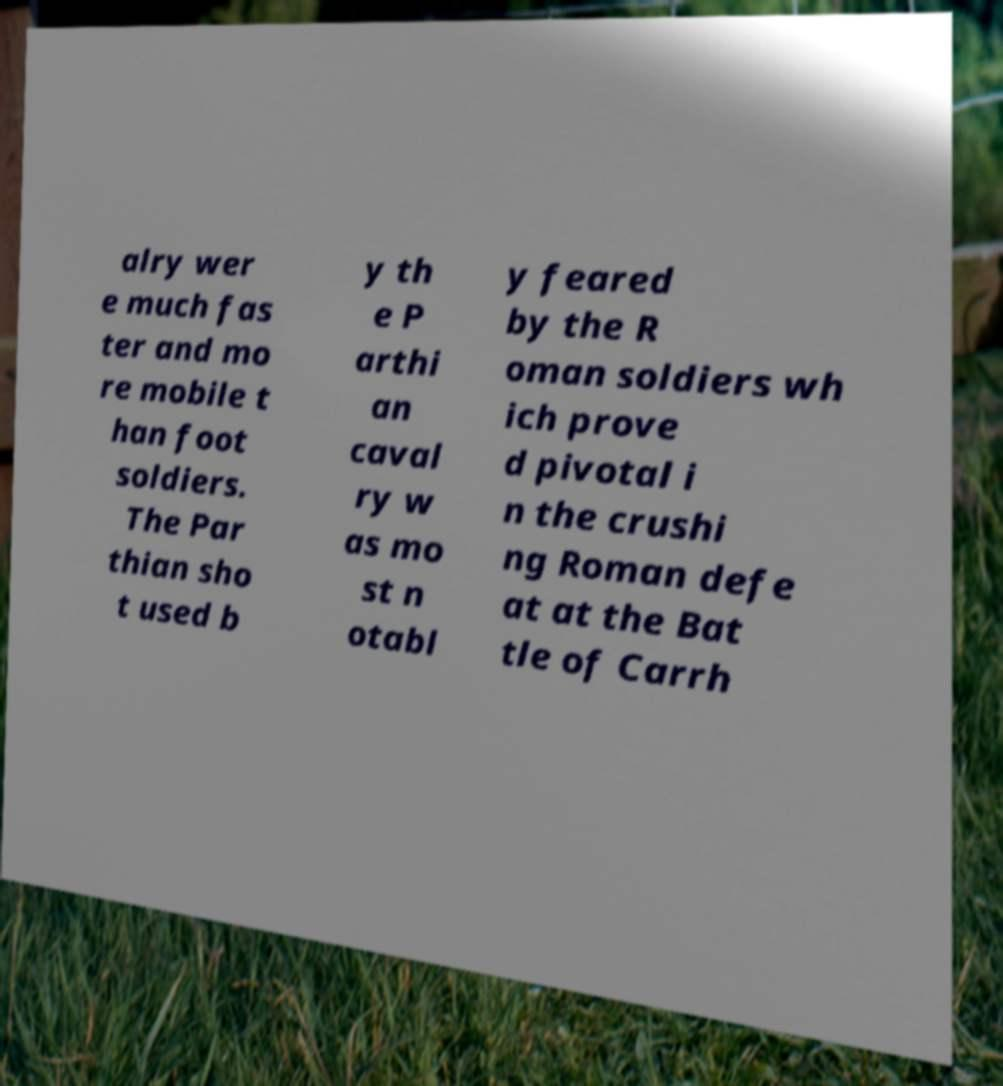Can you accurately transcribe the text from the provided image for me? alry wer e much fas ter and mo re mobile t han foot soldiers. The Par thian sho t used b y th e P arthi an caval ry w as mo st n otabl y feared by the R oman soldiers wh ich prove d pivotal i n the crushi ng Roman defe at at the Bat tle of Carrh 